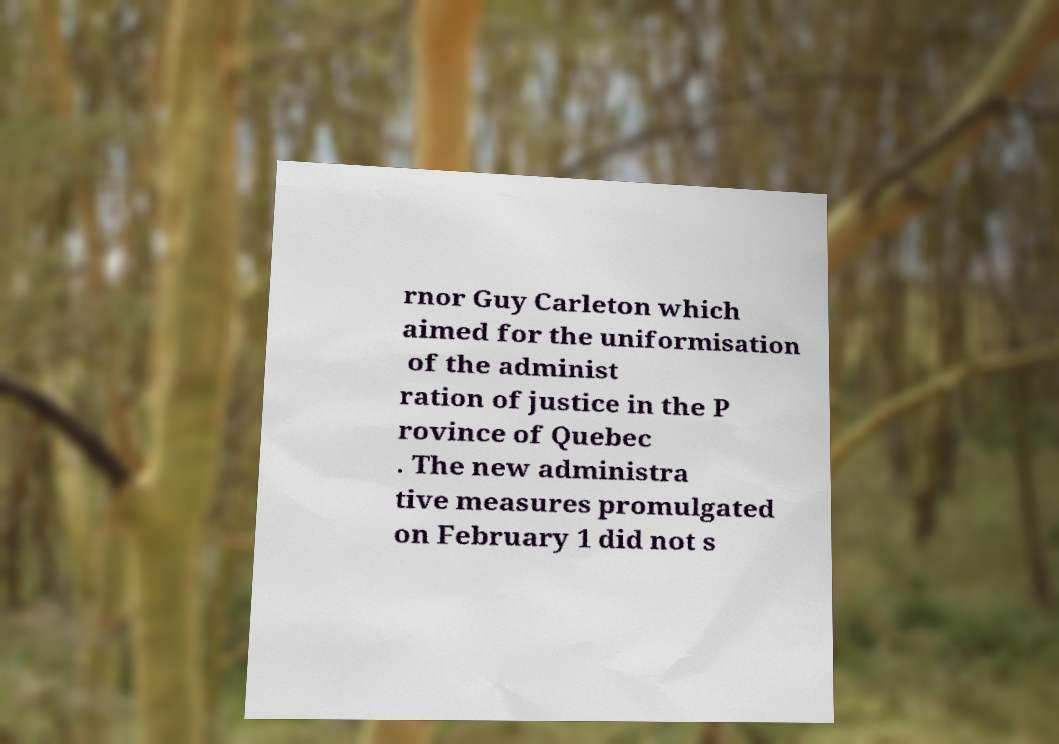Please read and relay the text visible in this image. What does it say? rnor Guy Carleton which aimed for the uniformisation of the administ ration of justice in the P rovince of Quebec . The new administra tive measures promulgated on February 1 did not s 